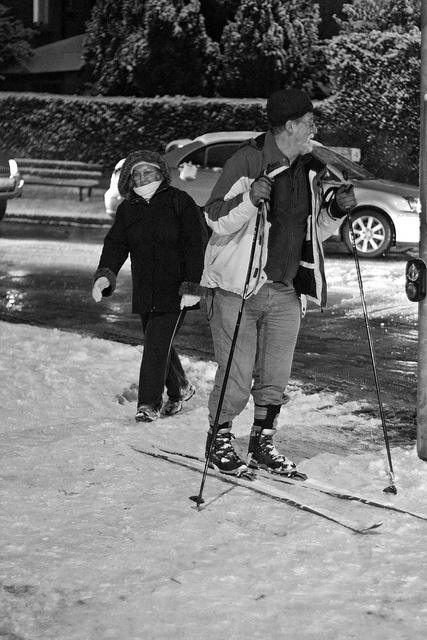Describe the objects in this image and their specific colors. I can see people in black, gray, darkgray, and lightgray tones, people in black, gray, darkgray, and lightgray tones, car in black, gray, darkgray, and white tones, skis in black, lightgray, darkgray, and gray tones, and bench in gray and black tones in this image. 